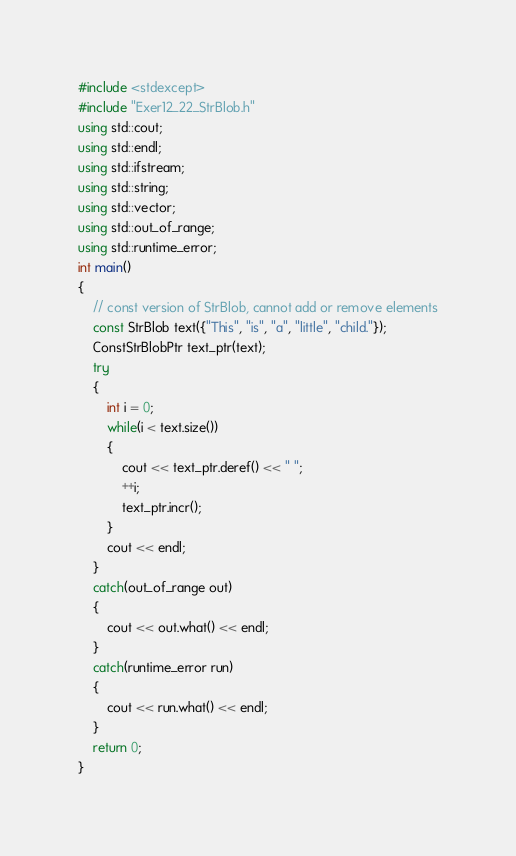<code> <loc_0><loc_0><loc_500><loc_500><_C++_>#include <stdexcept>
#include "Exer12_22_StrBlob.h"
using std::cout;
using std::endl;
using std::ifstream;
using std::string;
using std::vector;
using std::out_of_range;
using std::runtime_error;
int main()
{
    // const version of StrBlob, cannot add or remove elements
    const StrBlob text({"This", "is", "a", "little", "child."});
    ConstStrBlobPtr text_ptr(text);
    try
    {
        int i = 0;
        while(i < text.size())
        {
            cout << text_ptr.deref() << " ";
            ++i;
            text_ptr.incr();
        }
        cout << endl;
    }
    catch(out_of_range out)
    {
        cout << out.what() << endl;
    }
    catch(runtime_error run)
    {
        cout << run.what() << endl;
    }
    return 0;
}
</code> 